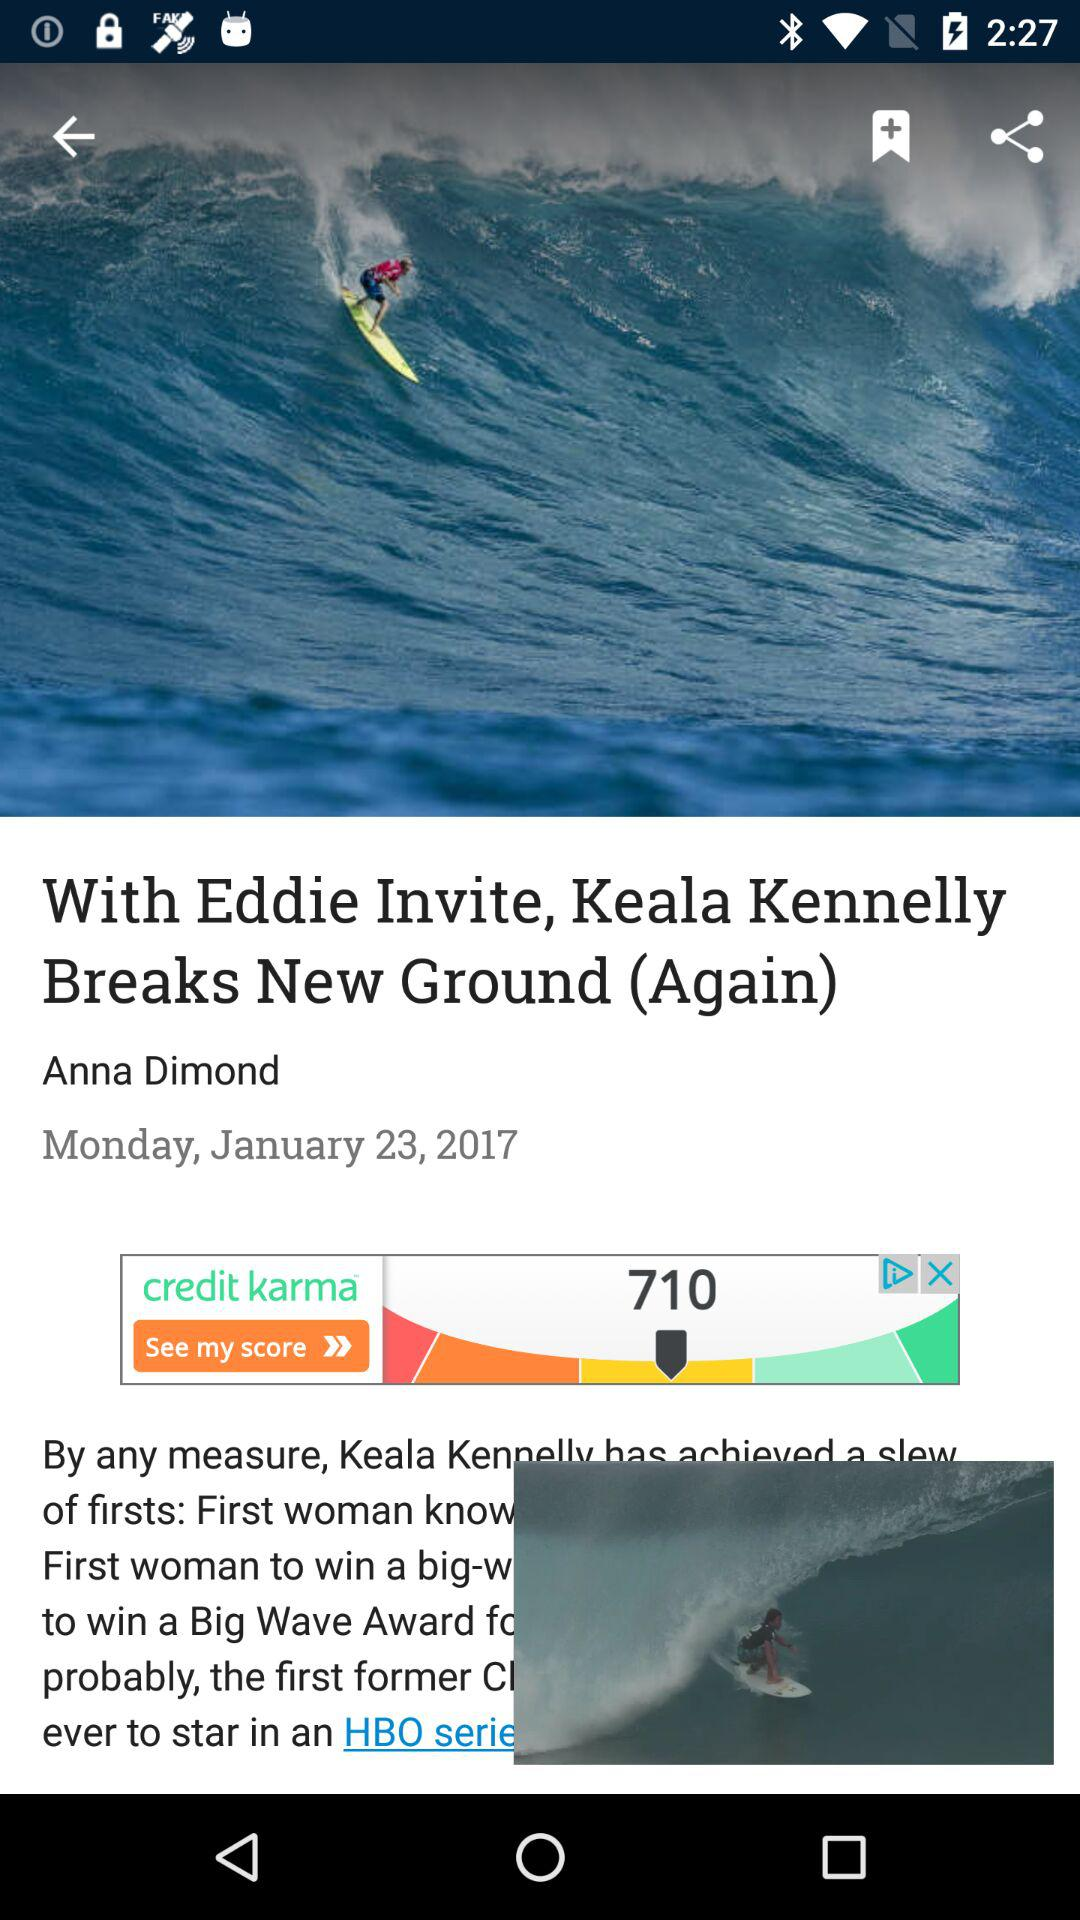Who is the author of the article? The author of the article is Anna Dimond. 